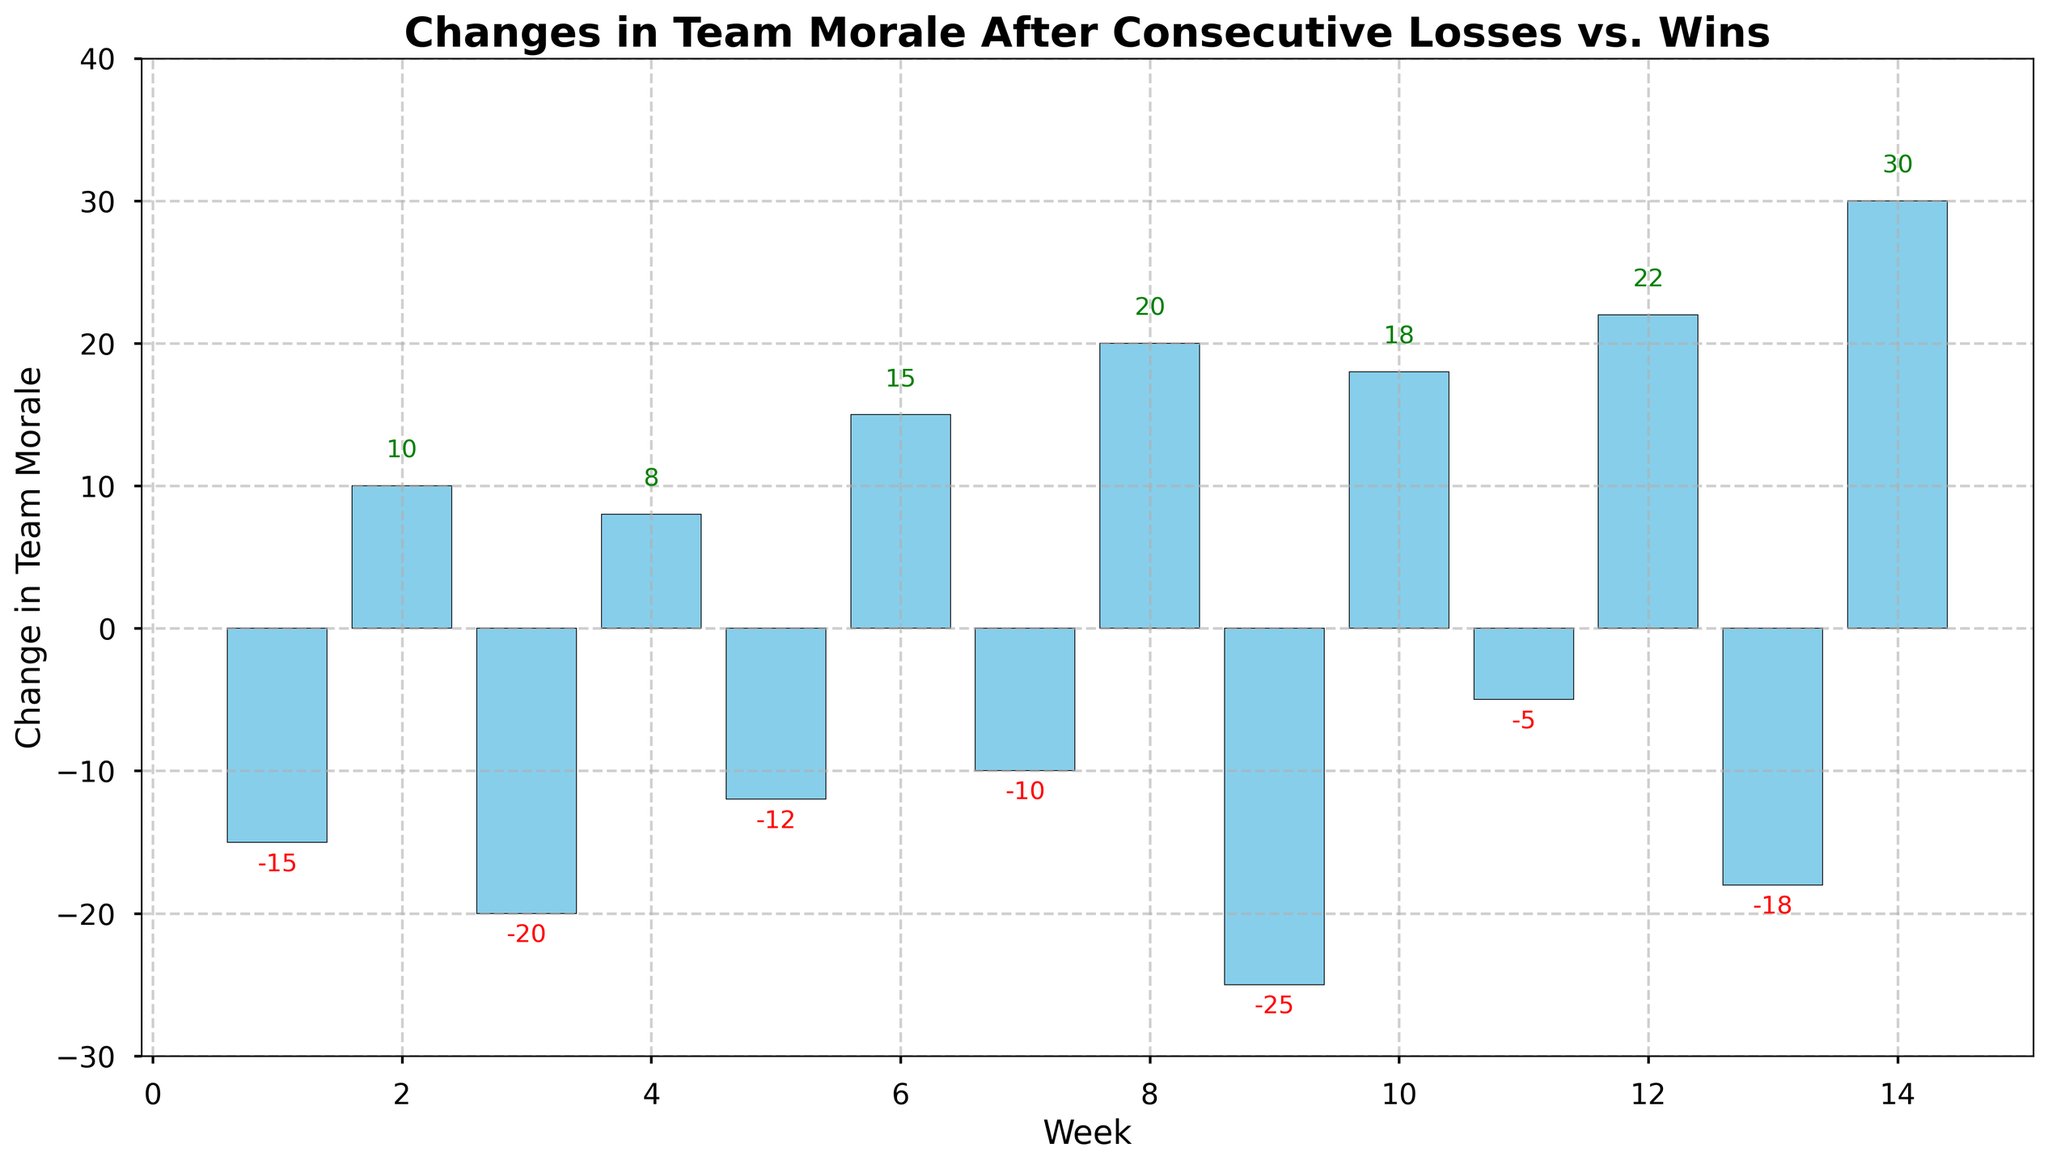What is the largest positive change in team morale? Scan the figure for the tallest bar pointing upwards, indicating the largest positive value.
Answer: 30 What is the largest negative change in team morale? Scan the figure for the deepest bar pointing downwards, indicating the largest negative value.
Answer: -25 Between which two consecutive weeks did the morale change the most? Calculate the absolute difference in morale change between all consecutive weeks and find the pair with the largest difference.
Answer: Week 8 to Week 9 What is the average change in team morale over the entire period? Sum the changes in team morale for all weeks and divide by the number of weeks to find the average.
Answer: 6.57 Which week had the smallest positive change in team morale? Identify the least tall bar pointing upwards.
Answer: Week 4 How many weeks experienced a negative change in team morale? Count the number of bars that extend below the zero line in the bar chart.
Answer: 7 Compare the change in team morale between Week 6 and Week 12. Which week had a higher morale change and by how much? Note the values for Week 6 (15) and Week 12 (22), then subtract one from the other.
Answer: Week 12 by 7 Which week had the smallest negative change in team morale? Identify the shallowest bar pointing downwards.
Answer: Week 11 By how much did the team morale change from Week 1 to Week 14 overall? Sum the changes in morale from Week 1 through Week 14 to find the total overall change.
Answer: 18 During which weeks was the team morale below zero? Identify the weeks where the bars are below the zero line.
Answer: Weeks 1, 3, 5, 7, 9, 11, 13 